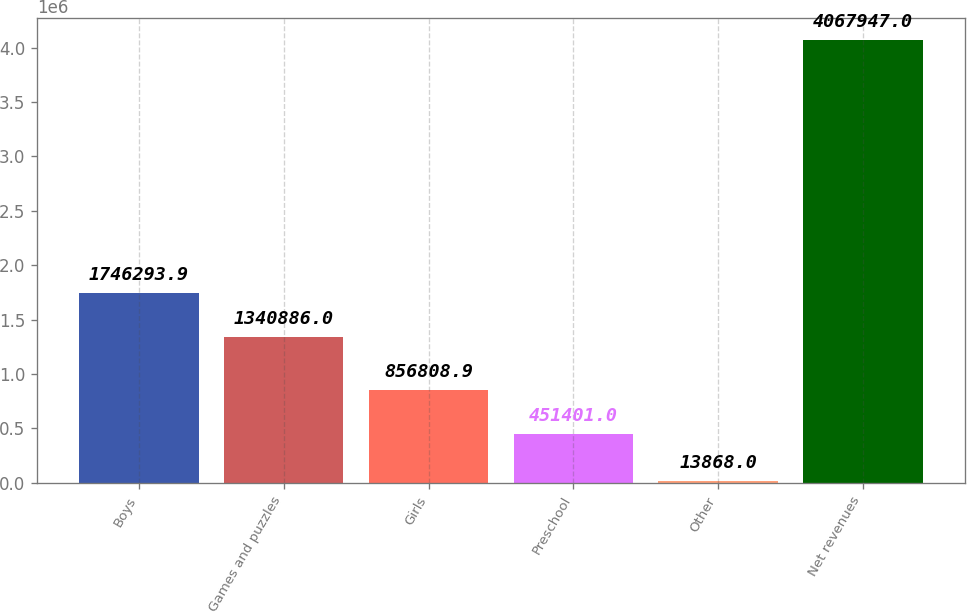<chart> <loc_0><loc_0><loc_500><loc_500><bar_chart><fcel>Boys<fcel>Games and puzzles<fcel>Girls<fcel>Preschool<fcel>Other<fcel>Net revenues<nl><fcel>1.74629e+06<fcel>1.34089e+06<fcel>856809<fcel>451401<fcel>13868<fcel>4.06795e+06<nl></chart> 